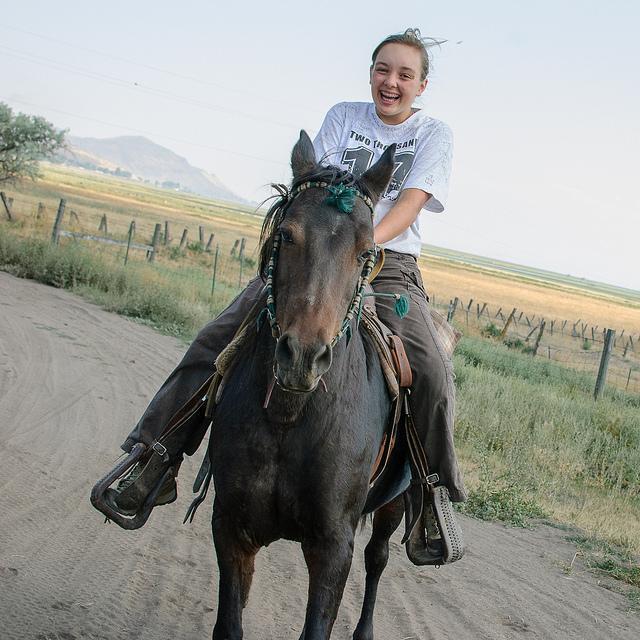Does the caption "The horse is behind the person." correctly depict the image?
Answer yes or no. No. 